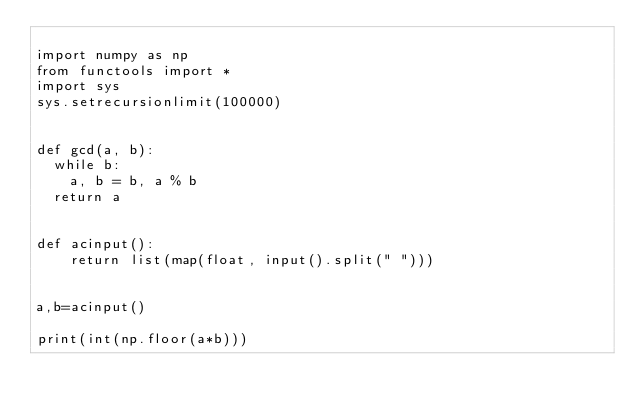Convert code to text. <code><loc_0><loc_0><loc_500><loc_500><_Python_>
import numpy as np
from functools import *
import sys
sys.setrecursionlimit(100000)


def gcd(a, b):
	while b:
		a, b = b, a % b
	return a


def acinput():
    return list(map(float, input().split(" ")))


a,b=acinput()

print(int(np.floor(a*b)))</code> 